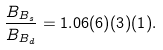Convert formula to latex. <formula><loc_0><loc_0><loc_500><loc_500>\frac { B _ { B _ { s } } } { B _ { B _ { d } } } = 1 . 0 6 ( 6 ) ( 3 ) ( 1 ) .</formula> 